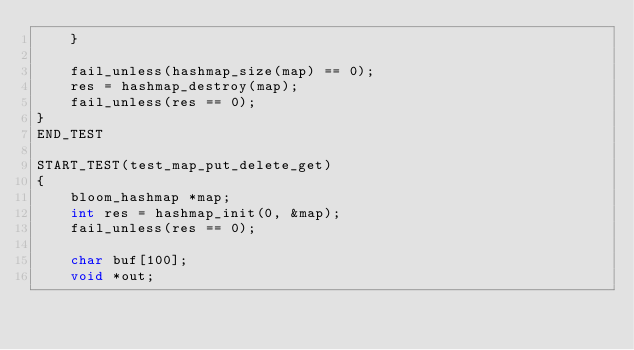<code> <loc_0><loc_0><loc_500><loc_500><_C_>    }

    fail_unless(hashmap_size(map) == 0);
    res = hashmap_destroy(map);
    fail_unless(res == 0);
}
END_TEST

START_TEST(test_map_put_delete_get)
{
    bloom_hashmap *map;
    int res = hashmap_init(0, &map);
    fail_unless(res == 0);

    char buf[100];
    void *out;</code> 